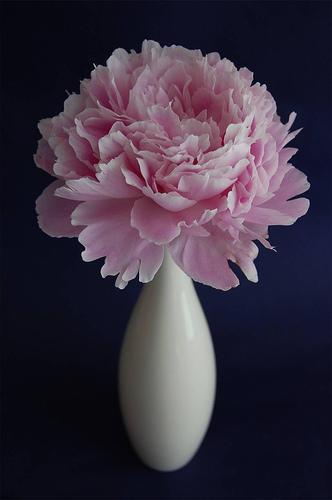How many skateboard wheels are red?
Give a very brief answer. 0. 